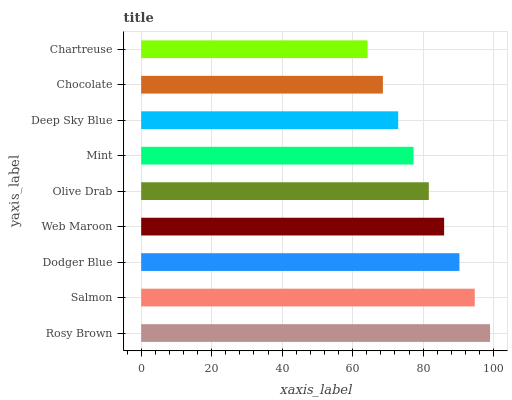Is Chartreuse the minimum?
Answer yes or no. Yes. Is Rosy Brown the maximum?
Answer yes or no. Yes. Is Salmon the minimum?
Answer yes or no. No. Is Salmon the maximum?
Answer yes or no. No. Is Rosy Brown greater than Salmon?
Answer yes or no. Yes. Is Salmon less than Rosy Brown?
Answer yes or no. Yes. Is Salmon greater than Rosy Brown?
Answer yes or no. No. Is Rosy Brown less than Salmon?
Answer yes or no. No. Is Olive Drab the high median?
Answer yes or no. Yes. Is Olive Drab the low median?
Answer yes or no. Yes. Is Web Maroon the high median?
Answer yes or no. No. Is Dodger Blue the low median?
Answer yes or no. No. 